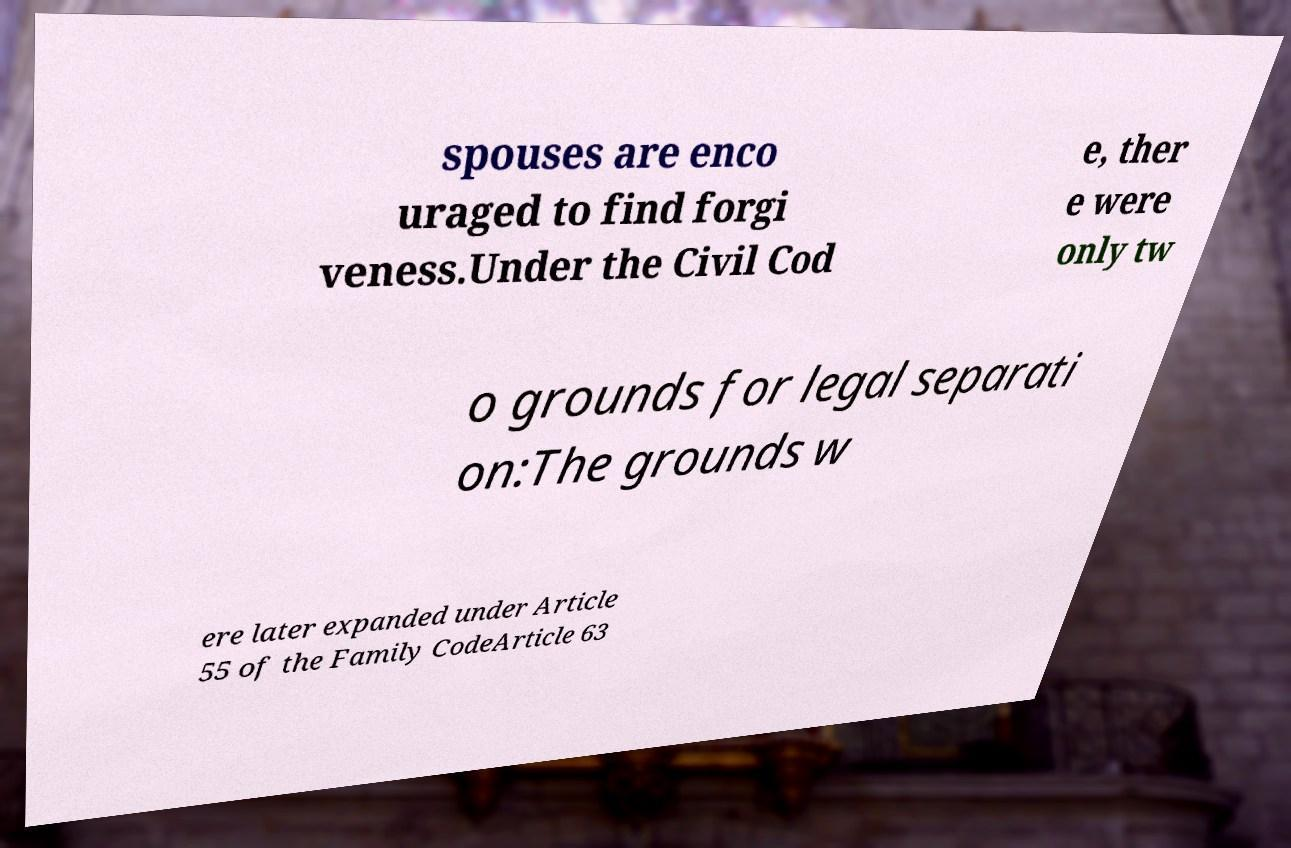What messages or text are displayed in this image? I need them in a readable, typed format. spouses are enco uraged to find forgi veness.Under the Civil Cod e, ther e were only tw o grounds for legal separati on:The grounds w ere later expanded under Article 55 of the Family CodeArticle 63 